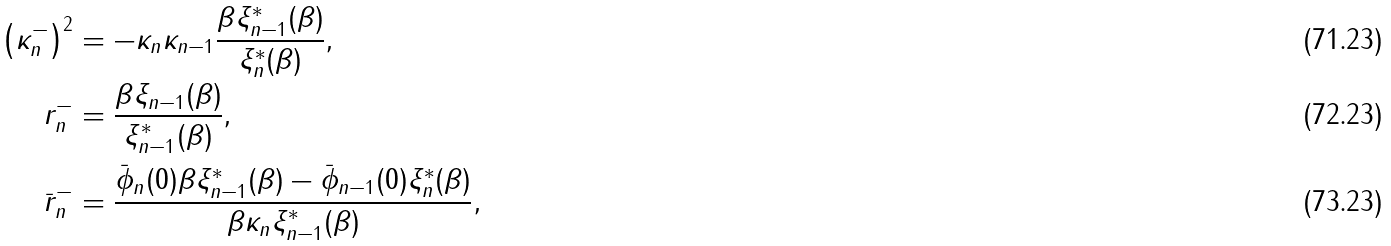Convert formula to latex. <formula><loc_0><loc_0><loc_500><loc_500>\left ( \kappa ^ { - } _ { n } \right ) ^ { 2 } & = - \kappa _ { n } \kappa _ { n - 1 } \frac { \beta \xi ^ { * } _ { n - 1 } ( \beta ) } { \xi ^ { * } _ { n } ( \beta ) } , \\ r ^ { - } _ { n } & = \frac { \beta \xi _ { n - 1 } ( \beta ) } { \xi ^ { * } _ { n - 1 } ( \beta ) } , \\ \bar { r } ^ { - } _ { n } & = \frac { \bar { \phi } _ { n } ( 0 ) \beta \xi ^ { * } _ { n - 1 } ( \beta ) - \bar { \phi } _ { n - 1 } ( 0 ) \xi ^ { * } _ { n } ( \beta ) } { \beta \kappa _ { n } \xi ^ { * } _ { n - 1 } ( \beta ) } ,</formula> 